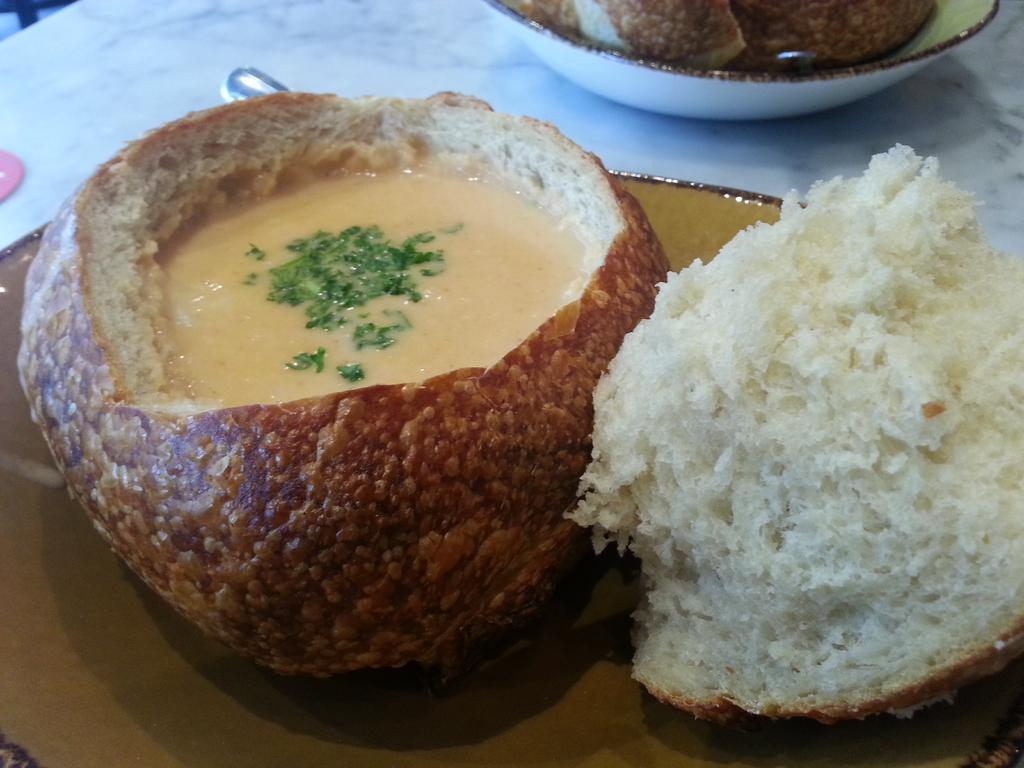What is the main dish featured in the foreground of the image? There is a clam chowder on a platter in the foreground of the image. What type of food can be seen in the background of the image? There is a bowl full of breads in the background of the image. Where is the bowl of breads located? The bowl of breads is placed on a table. How many horses are present in the image? There are no horses present in the image. Is the family gathered around the table in the image? The provided facts do not mention a family or any people in the image, so we cannot determine if they are gathered around the table. 